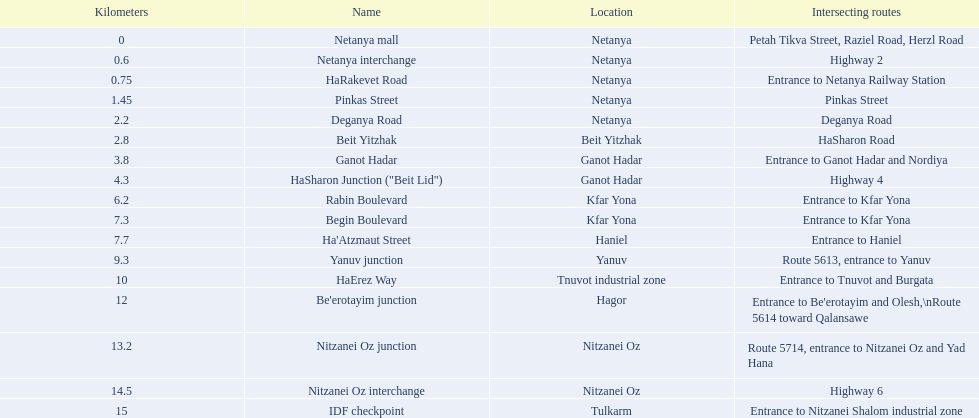What are all the titles? Netanya mall, Netanya interchange, HaRakevet Road, Pinkas Street, Deganya Road, Beit Yitzhak, Ganot Hadar, HaSharon Junction ("Beit Lid"), Rabin Boulevard, Begin Boulevard, Ha'Atzmaut Street, Yanuv junction, HaErez Way, Be'erotayim junction, Nitzanei Oz junction, Nitzanei Oz interchange, IDF checkpoint. Where do they cross? Petah Tikva Street, Raziel Road, Herzl Road, Highway 2, Entrance to Netanya Railway Station, Pinkas Street, Deganya Road, HaSharon Road, Entrance to Ganot Hadar and Nordiya, Highway 4, Entrance to Kfar Yona, Entrance to Kfar Yona, Entrance to Haniel, Route 5613, entrance to Yanuv, Entrance to Tnuvot and Burgata, Entrance to Be'erotayim and Olesh,\nRoute 5614 toward Qalansawe, Route 5714, entrance to Nitzanei Oz and Yad Hana, Highway 6, Entrance to Nitzanei Shalom industrial zone. And which one has an intersection with rabin boulevard? Begin Boulevard. 